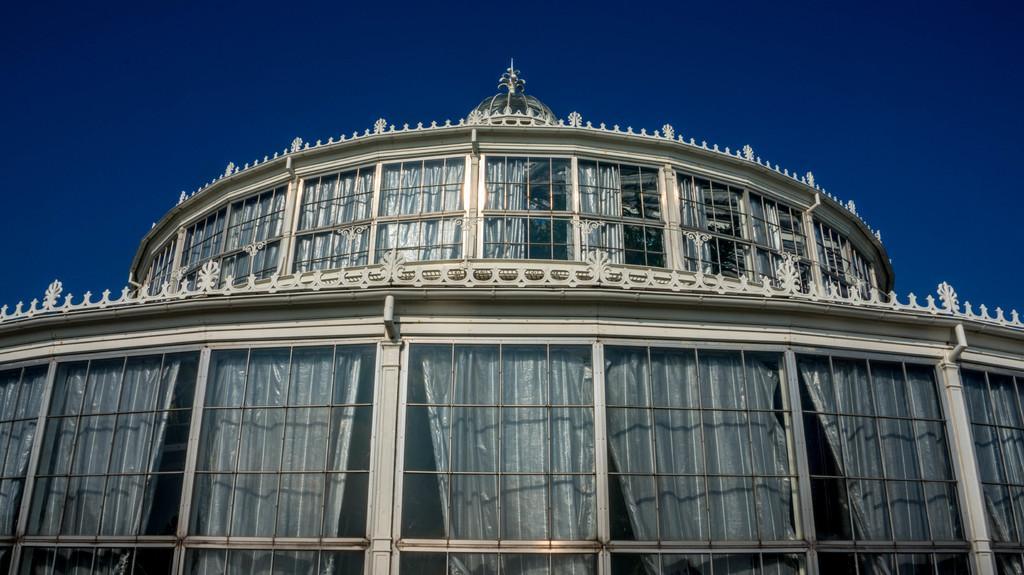In one or two sentences, can you explain what this image depicts? In this image we can see a building with group of windows and curtains. In the background, we can see the sky. 